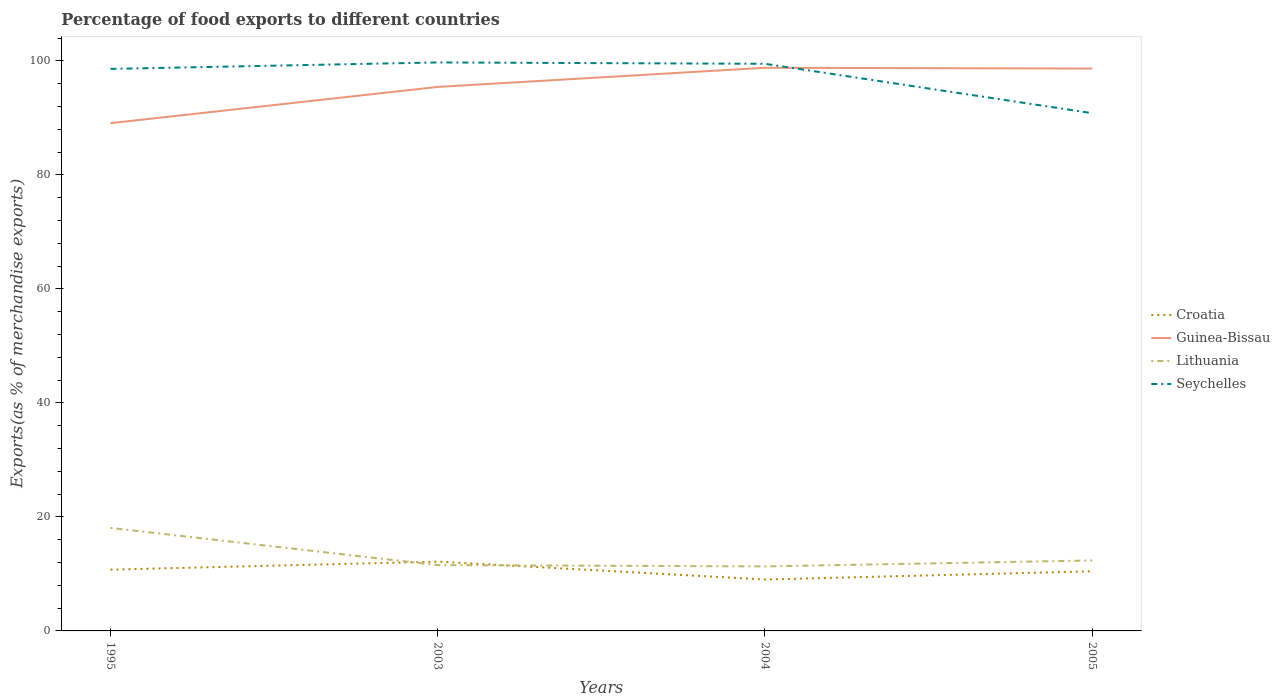How many different coloured lines are there?
Keep it short and to the point. 4. Across all years, what is the maximum percentage of exports to different countries in Croatia?
Provide a short and direct response. 9.02. In which year was the percentage of exports to different countries in Croatia maximum?
Offer a very short reply. 2004. What is the total percentage of exports to different countries in Croatia in the graph?
Your answer should be very brief. -1.41. What is the difference between the highest and the second highest percentage of exports to different countries in Lithuania?
Ensure brevity in your answer.  6.75. Is the percentage of exports to different countries in Lithuania strictly greater than the percentage of exports to different countries in Guinea-Bissau over the years?
Keep it short and to the point. Yes. How many lines are there?
Offer a very short reply. 4. What is the difference between two consecutive major ticks on the Y-axis?
Make the answer very short. 20. Are the values on the major ticks of Y-axis written in scientific E-notation?
Your response must be concise. No. Does the graph contain grids?
Keep it short and to the point. No. What is the title of the graph?
Make the answer very short. Percentage of food exports to different countries. What is the label or title of the Y-axis?
Provide a short and direct response. Exports(as % of merchandise exports). What is the Exports(as % of merchandise exports) in Croatia in 1995?
Offer a terse response. 10.75. What is the Exports(as % of merchandise exports) in Guinea-Bissau in 1995?
Your answer should be very brief. 89.08. What is the Exports(as % of merchandise exports) in Lithuania in 1995?
Offer a terse response. 18.07. What is the Exports(as % of merchandise exports) of Seychelles in 1995?
Offer a very short reply. 98.6. What is the Exports(as % of merchandise exports) of Croatia in 2003?
Make the answer very short. 12.16. What is the Exports(as % of merchandise exports) of Guinea-Bissau in 2003?
Keep it short and to the point. 95.44. What is the Exports(as % of merchandise exports) of Lithuania in 2003?
Your answer should be very brief. 11.55. What is the Exports(as % of merchandise exports) of Seychelles in 2003?
Your answer should be compact. 99.73. What is the Exports(as % of merchandise exports) in Croatia in 2004?
Make the answer very short. 9.02. What is the Exports(as % of merchandise exports) of Guinea-Bissau in 2004?
Ensure brevity in your answer.  98.79. What is the Exports(as % of merchandise exports) in Lithuania in 2004?
Give a very brief answer. 11.32. What is the Exports(as % of merchandise exports) of Seychelles in 2004?
Your answer should be very brief. 99.49. What is the Exports(as % of merchandise exports) in Croatia in 2005?
Keep it short and to the point. 10.46. What is the Exports(as % of merchandise exports) in Guinea-Bissau in 2005?
Ensure brevity in your answer.  98.66. What is the Exports(as % of merchandise exports) of Lithuania in 2005?
Your response must be concise. 12.36. What is the Exports(as % of merchandise exports) of Seychelles in 2005?
Give a very brief answer. 90.83. Across all years, what is the maximum Exports(as % of merchandise exports) in Croatia?
Offer a very short reply. 12.16. Across all years, what is the maximum Exports(as % of merchandise exports) in Guinea-Bissau?
Provide a short and direct response. 98.79. Across all years, what is the maximum Exports(as % of merchandise exports) of Lithuania?
Ensure brevity in your answer.  18.07. Across all years, what is the maximum Exports(as % of merchandise exports) of Seychelles?
Give a very brief answer. 99.73. Across all years, what is the minimum Exports(as % of merchandise exports) of Croatia?
Offer a terse response. 9.02. Across all years, what is the minimum Exports(as % of merchandise exports) of Guinea-Bissau?
Keep it short and to the point. 89.08. Across all years, what is the minimum Exports(as % of merchandise exports) of Lithuania?
Give a very brief answer. 11.32. Across all years, what is the minimum Exports(as % of merchandise exports) of Seychelles?
Provide a succinct answer. 90.83. What is the total Exports(as % of merchandise exports) in Croatia in the graph?
Provide a short and direct response. 42.39. What is the total Exports(as % of merchandise exports) in Guinea-Bissau in the graph?
Your answer should be very brief. 381.97. What is the total Exports(as % of merchandise exports) in Lithuania in the graph?
Your answer should be very brief. 53.3. What is the total Exports(as % of merchandise exports) in Seychelles in the graph?
Keep it short and to the point. 388.65. What is the difference between the Exports(as % of merchandise exports) of Croatia in 1995 and that in 2003?
Provide a short and direct response. -1.41. What is the difference between the Exports(as % of merchandise exports) in Guinea-Bissau in 1995 and that in 2003?
Keep it short and to the point. -6.36. What is the difference between the Exports(as % of merchandise exports) in Lithuania in 1995 and that in 2003?
Your answer should be very brief. 6.52. What is the difference between the Exports(as % of merchandise exports) of Seychelles in 1995 and that in 2003?
Give a very brief answer. -1.14. What is the difference between the Exports(as % of merchandise exports) in Croatia in 1995 and that in 2004?
Your answer should be compact. 1.73. What is the difference between the Exports(as % of merchandise exports) of Guinea-Bissau in 1995 and that in 2004?
Offer a very short reply. -9.72. What is the difference between the Exports(as % of merchandise exports) of Lithuania in 1995 and that in 2004?
Ensure brevity in your answer.  6.75. What is the difference between the Exports(as % of merchandise exports) in Seychelles in 1995 and that in 2004?
Your answer should be compact. -0.89. What is the difference between the Exports(as % of merchandise exports) in Croatia in 1995 and that in 2005?
Offer a very short reply. 0.29. What is the difference between the Exports(as % of merchandise exports) in Guinea-Bissau in 1995 and that in 2005?
Provide a succinct answer. -9.58. What is the difference between the Exports(as % of merchandise exports) of Lithuania in 1995 and that in 2005?
Your answer should be very brief. 5.71. What is the difference between the Exports(as % of merchandise exports) in Seychelles in 1995 and that in 2005?
Offer a terse response. 7.77. What is the difference between the Exports(as % of merchandise exports) in Croatia in 2003 and that in 2004?
Offer a terse response. 3.14. What is the difference between the Exports(as % of merchandise exports) of Guinea-Bissau in 2003 and that in 2004?
Your answer should be very brief. -3.36. What is the difference between the Exports(as % of merchandise exports) of Lithuania in 2003 and that in 2004?
Keep it short and to the point. 0.23. What is the difference between the Exports(as % of merchandise exports) in Seychelles in 2003 and that in 2004?
Give a very brief answer. 0.24. What is the difference between the Exports(as % of merchandise exports) in Croatia in 2003 and that in 2005?
Ensure brevity in your answer.  1.7. What is the difference between the Exports(as % of merchandise exports) of Guinea-Bissau in 2003 and that in 2005?
Offer a terse response. -3.22. What is the difference between the Exports(as % of merchandise exports) in Lithuania in 2003 and that in 2005?
Ensure brevity in your answer.  -0.82. What is the difference between the Exports(as % of merchandise exports) of Seychelles in 2003 and that in 2005?
Your answer should be very brief. 8.9. What is the difference between the Exports(as % of merchandise exports) of Croatia in 2004 and that in 2005?
Provide a succinct answer. -1.44. What is the difference between the Exports(as % of merchandise exports) in Guinea-Bissau in 2004 and that in 2005?
Make the answer very short. 0.13. What is the difference between the Exports(as % of merchandise exports) in Lithuania in 2004 and that in 2005?
Keep it short and to the point. -1.04. What is the difference between the Exports(as % of merchandise exports) of Seychelles in 2004 and that in 2005?
Your response must be concise. 8.66. What is the difference between the Exports(as % of merchandise exports) in Croatia in 1995 and the Exports(as % of merchandise exports) in Guinea-Bissau in 2003?
Your answer should be compact. -84.69. What is the difference between the Exports(as % of merchandise exports) in Croatia in 1995 and the Exports(as % of merchandise exports) in Lithuania in 2003?
Offer a terse response. -0.8. What is the difference between the Exports(as % of merchandise exports) of Croatia in 1995 and the Exports(as % of merchandise exports) of Seychelles in 2003?
Keep it short and to the point. -88.98. What is the difference between the Exports(as % of merchandise exports) of Guinea-Bissau in 1995 and the Exports(as % of merchandise exports) of Lithuania in 2003?
Provide a succinct answer. 77.53. What is the difference between the Exports(as % of merchandise exports) of Guinea-Bissau in 1995 and the Exports(as % of merchandise exports) of Seychelles in 2003?
Offer a very short reply. -10.66. What is the difference between the Exports(as % of merchandise exports) of Lithuania in 1995 and the Exports(as % of merchandise exports) of Seychelles in 2003?
Offer a terse response. -81.66. What is the difference between the Exports(as % of merchandise exports) of Croatia in 1995 and the Exports(as % of merchandise exports) of Guinea-Bissau in 2004?
Your answer should be very brief. -88.04. What is the difference between the Exports(as % of merchandise exports) of Croatia in 1995 and the Exports(as % of merchandise exports) of Lithuania in 2004?
Keep it short and to the point. -0.57. What is the difference between the Exports(as % of merchandise exports) of Croatia in 1995 and the Exports(as % of merchandise exports) of Seychelles in 2004?
Your response must be concise. -88.74. What is the difference between the Exports(as % of merchandise exports) in Guinea-Bissau in 1995 and the Exports(as % of merchandise exports) in Lithuania in 2004?
Offer a very short reply. 77.76. What is the difference between the Exports(as % of merchandise exports) of Guinea-Bissau in 1995 and the Exports(as % of merchandise exports) of Seychelles in 2004?
Offer a terse response. -10.41. What is the difference between the Exports(as % of merchandise exports) in Lithuania in 1995 and the Exports(as % of merchandise exports) in Seychelles in 2004?
Give a very brief answer. -81.42. What is the difference between the Exports(as % of merchandise exports) of Croatia in 1995 and the Exports(as % of merchandise exports) of Guinea-Bissau in 2005?
Your response must be concise. -87.91. What is the difference between the Exports(as % of merchandise exports) of Croatia in 1995 and the Exports(as % of merchandise exports) of Lithuania in 2005?
Provide a succinct answer. -1.61. What is the difference between the Exports(as % of merchandise exports) in Croatia in 1995 and the Exports(as % of merchandise exports) in Seychelles in 2005?
Provide a short and direct response. -80.08. What is the difference between the Exports(as % of merchandise exports) in Guinea-Bissau in 1995 and the Exports(as % of merchandise exports) in Lithuania in 2005?
Offer a terse response. 76.71. What is the difference between the Exports(as % of merchandise exports) in Guinea-Bissau in 1995 and the Exports(as % of merchandise exports) in Seychelles in 2005?
Offer a very short reply. -1.75. What is the difference between the Exports(as % of merchandise exports) in Lithuania in 1995 and the Exports(as % of merchandise exports) in Seychelles in 2005?
Your answer should be very brief. -72.76. What is the difference between the Exports(as % of merchandise exports) of Croatia in 2003 and the Exports(as % of merchandise exports) of Guinea-Bissau in 2004?
Make the answer very short. -86.64. What is the difference between the Exports(as % of merchandise exports) of Croatia in 2003 and the Exports(as % of merchandise exports) of Lithuania in 2004?
Ensure brevity in your answer.  0.84. What is the difference between the Exports(as % of merchandise exports) of Croatia in 2003 and the Exports(as % of merchandise exports) of Seychelles in 2004?
Offer a terse response. -87.33. What is the difference between the Exports(as % of merchandise exports) in Guinea-Bissau in 2003 and the Exports(as % of merchandise exports) in Lithuania in 2004?
Keep it short and to the point. 84.12. What is the difference between the Exports(as % of merchandise exports) of Guinea-Bissau in 2003 and the Exports(as % of merchandise exports) of Seychelles in 2004?
Give a very brief answer. -4.05. What is the difference between the Exports(as % of merchandise exports) in Lithuania in 2003 and the Exports(as % of merchandise exports) in Seychelles in 2004?
Give a very brief answer. -87.94. What is the difference between the Exports(as % of merchandise exports) of Croatia in 2003 and the Exports(as % of merchandise exports) of Guinea-Bissau in 2005?
Your response must be concise. -86.5. What is the difference between the Exports(as % of merchandise exports) in Croatia in 2003 and the Exports(as % of merchandise exports) in Lithuania in 2005?
Make the answer very short. -0.21. What is the difference between the Exports(as % of merchandise exports) of Croatia in 2003 and the Exports(as % of merchandise exports) of Seychelles in 2005?
Offer a very short reply. -78.67. What is the difference between the Exports(as % of merchandise exports) in Guinea-Bissau in 2003 and the Exports(as % of merchandise exports) in Lithuania in 2005?
Your response must be concise. 83.07. What is the difference between the Exports(as % of merchandise exports) of Guinea-Bissau in 2003 and the Exports(as % of merchandise exports) of Seychelles in 2005?
Give a very brief answer. 4.61. What is the difference between the Exports(as % of merchandise exports) in Lithuania in 2003 and the Exports(as % of merchandise exports) in Seychelles in 2005?
Offer a very short reply. -79.28. What is the difference between the Exports(as % of merchandise exports) in Croatia in 2004 and the Exports(as % of merchandise exports) in Guinea-Bissau in 2005?
Ensure brevity in your answer.  -89.64. What is the difference between the Exports(as % of merchandise exports) of Croatia in 2004 and the Exports(as % of merchandise exports) of Lithuania in 2005?
Provide a short and direct response. -3.34. What is the difference between the Exports(as % of merchandise exports) in Croatia in 2004 and the Exports(as % of merchandise exports) in Seychelles in 2005?
Ensure brevity in your answer.  -81.81. What is the difference between the Exports(as % of merchandise exports) of Guinea-Bissau in 2004 and the Exports(as % of merchandise exports) of Lithuania in 2005?
Offer a terse response. 86.43. What is the difference between the Exports(as % of merchandise exports) of Guinea-Bissau in 2004 and the Exports(as % of merchandise exports) of Seychelles in 2005?
Ensure brevity in your answer.  7.97. What is the difference between the Exports(as % of merchandise exports) in Lithuania in 2004 and the Exports(as % of merchandise exports) in Seychelles in 2005?
Ensure brevity in your answer.  -79.51. What is the average Exports(as % of merchandise exports) in Croatia per year?
Give a very brief answer. 10.6. What is the average Exports(as % of merchandise exports) in Guinea-Bissau per year?
Your answer should be very brief. 95.49. What is the average Exports(as % of merchandise exports) in Lithuania per year?
Make the answer very short. 13.32. What is the average Exports(as % of merchandise exports) in Seychelles per year?
Your answer should be compact. 97.16. In the year 1995, what is the difference between the Exports(as % of merchandise exports) in Croatia and Exports(as % of merchandise exports) in Guinea-Bissau?
Your answer should be very brief. -78.33. In the year 1995, what is the difference between the Exports(as % of merchandise exports) of Croatia and Exports(as % of merchandise exports) of Lithuania?
Your response must be concise. -7.32. In the year 1995, what is the difference between the Exports(as % of merchandise exports) of Croatia and Exports(as % of merchandise exports) of Seychelles?
Your answer should be compact. -87.85. In the year 1995, what is the difference between the Exports(as % of merchandise exports) in Guinea-Bissau and Exports(as % of merchandise exports) in Lithuania?
Keep it short and to the point. 71.01. In the year 1995, what is the difference between the Exports(as % of merchandise exports) of Guinea-Bissau and Exports(as % of merchandise exports) of Seychelles?
Keep it short and to the point. -9.52. In the year 1995, what is the difference between the Exports(as % of merchandise exports) in Lithuania and Exports(as % of merchandise exports) in Seychelles?
Keep it short and to the point. -80.53. In the year 2003, what is the difference between the Exports(as % of merchandise exports) of Croatia and Exports(as % of merchandise exports) of Guinea-Bissau?
Give a very brief answer. -83.28. In the year 2003, what is the difference between the Exports(as % of merchandise exports) of Croatia and Exports(as % of merchandise exports) of Lithuania?
Your answer should be very brief. 0.61. In the year 2003, what is the difference between the Exports(as % of merchandise exports) of Croatia and Exports(as % of merchandise exports) of Seychelles?
Ensure brevity in your answer.  -87.57. In the year 2003, what is the difference between the Exports(as % of merchandise exports) in Guinea-Bissau and Exports(as % of merchandise exports) in Lithuania?
Offer a terse response. 83.89. In the year 2003, what is the difference between the Exports(as % of merchandise exports) of Guinea-Bissau and Exports(as % of merchandise exports) of Seychelles?
Offer a very short reply. -4.29. In the year 2003, what is the difference between the Exports(as % of merchandise exports) of Lithuania and Exports(as % of merchandise exports) of Seychelles?
Provide a succinct answer. -88.18. In the year 2004, what is the difference between the Exports(as % of merchandise exports) in Croatia and Exports(as % of merchandise exports) in Guinea-Bissau?
Provide a succinct answer. -89.77. In the year 2004, what is the difference between the Exports(as % of merchandise exports) of Croatia and Exports(as % of merchandise exports) of Lithuania?
Provide a short and direct response. -2.3. In the year 2004, what is the difference between the Exports(as % of merchandise exports) in Croatia and Exports(as % of merchandise exports) in Seychelles?
Ensure brevity in your answer.  -90.47. In the year 2004, what is the difference between the Exports(as % of merchandise exports) in Guinea-Bissau and Exports(as % of merchandise exports) in Lithuania?
Give a very brief answer. 87.47. In the year 2004, what is the difference between the Exports(as % of merchandise exports) in Guinea-Bissau and Exports(as % of merchandise exports) in Seychelles?
Provide a short and direct response. -0.7. In the year 2004, what is the difference between the Exports(as % of merchandise exports) in Lithuania and Exports(as % of merchandise exports) in Seychelles?
Ensure brevity in your answer.  -88.17. In the year 2005, what is the difference between the Exports(as % of merchandise exports) of Croatia and Exports(as % of merchandise exports) of Guinea-Bissau?
Your answer should be compact. -88.2. In the year 2005, what is the difference between the Exports(as % of merchandise exports) in Croatia and Exports(as % of merchandise exports) in Lithuania?
Your response must be concise. -1.9. In the year 2005, what is the difference between the Exports(as % of merchandise exports) of Croatia and Exports(as % of merchandise exports) of Seychelles?
Provide a succinct answer. -80.37. In the year 2005, what is the difference between the Exports(as % of merchandise exports) of Guinea-Bissau and Exports(as % of merchandise exports) of Lithuania?
Give a very brief answer. 86.3. In the year 2005, what is the difference between the Exports(as % of merchandise exports) of Guinea-Bissau and Exports(as % of merchandise exports) of Seychelles?
Provide a succinct answer. 7.83. In the year 2005, what is the difference between the Exports(as % of merchandise exports) in Lithuania and Exports(as % of merchandise exports) in Seychelles?
Make the answer very short. -78.47. What is the ratio of the Exports(as % of merchandise exports) in Croatia in 1995 to that in 2003?
Your response must be concise. 0.88. What is the ratio of the Exports(as % of merchandise exports) in Guinea-Bissau in 1995 to that in 2003?
Make the answer very short. 0.93. What is the ratio of the Exports(as % of merchandise exports) in Lithuania in 1995 to that in 2003?
Make the answer very short. 1.56. What is the ratio of the Exports(as % of merchandise exports) of Croatia in 1995 to that in 2004?
Offer a terse response. 1.19. What is the ratio of the Exports(as % of merchandise exports) in Guinea-Bissau in 1995 to that in 2004?
Your answer should be very brief. 0.9. What is the ratio of the Exports(as % of merchandise exports) in Lithuania in 1995 to that in 2004?
Keep it short and to the point. 1.6. What is the ratio of the Exports(as % of merchandise exports) of Seychelles in 1995 to that in 2004?
Ensure brevity in your answer.  0.99. What is the ratio of the Exports(as % of merchandise exports) of Croatia in 1995 to that in 2005?
Provide a succinct answer. 1.03. What is the ratio of the Exports(as % of merchandise exports) of Guinea-Bissau in 1995 to that in 2005?
Offer a terse response. 0.9. What is the ratio of the Exports(as % of merchandise exports) of Lithuania in 1995 to that in 2005?
Offer a very short reply. 1.46. What is the ratio of the Exports(as % of merchandise exports) in Seychelles in 1995 to that in 2005?
Make the answer very short. 1.09. What is the ratio of the Exports(as % of merchandise exports) of Croatia in 2003 to that in 2004?
Keep it short and to the point. 1.35. What is the ratio of the Exports(as % of merchandise exports) of Guinea-Bissau in 2003 to that in 2004?
Your answer should be very brief. 0.97. What is the ratio of the Exports(as % of merchandise exports) of Lithuania in 2003 to that in 2004?
Your answer should be very brief. 1.02. What is the ratio of the Exports(as % of merchandise exports) in Croatia in 2003 to that in 2005?
Your answer should be compact. 1.16. What is the ratio of the Exports(as % of merchandise exports) of Guinea-Bissau in 2003 to that in 2005?
Keep it short and to the point. 0.97. What is the ratio of the Exports(as % of merchandise exports) of Lithuania in 2003 to that in 2005?
Make the answer very short. 0.93. What is the ratio of the Exports(as % of merchandise exports) in Seychelles in 2003 to that in 2005?
Your response must be concise. 1.1. What is the ratio of the Exports(as % of merchandise exports) in Croatia in 2004 to that in 2005?
Offer a very short reply. 0.86. What is the ratio of the Exports(as % of merchandise exports) in Lithuania in 2004 to that in 2005?
Make the answer very short. 0.92. What is the ratio of the Exports(as % of merchandise exports) of Seychelles in 2004 to that in 2005?
Offer a terse response. 1.1. What is the difference between the highest and the second highest Exports(as % of merchandise exports) in Croatia?
Make the answer very short. 1.41. What is the difference between the highest and the second highest Exports(as % of merchandise exports) of Guinea-Bissau?
Your answer should be very brief. 0.13. What is the difference between the highest and the second highest Exports(as % of merchandise exports) in Lithuania?
Provide a succinct answer. 5.71. What is the difference between the highest and the second highest Exports(as % of merchandise exports) in Seychelles?
Your answer should be very brief. 0.24. What is the difference between the highest and the lowest Exports(as % of merchandise exports) in Croatia?
Your answer should be very brief. 3.14. What is the difference between the highest and the lowest Exports(as % of merchandise exports) of Guinea-Bissau?
Offer a very short reply. 9.72. What is the difference between the highest and the lowest Exports(as % of merchandise exports) of Lithuania?
Your answer should be very brief. 6.75. What is the difference between the highest and the lowest Exports(as % of merchandise exports) of Seychelles?
Your answer should be compact. 8.9. 